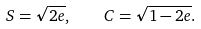Convert formula to latex. <formula><loc_0><loc_0><loc_500><loc_500>S = \sqrt { 2 e } , \quad C = \sqrt { 1 - 2 e } .</formula> 